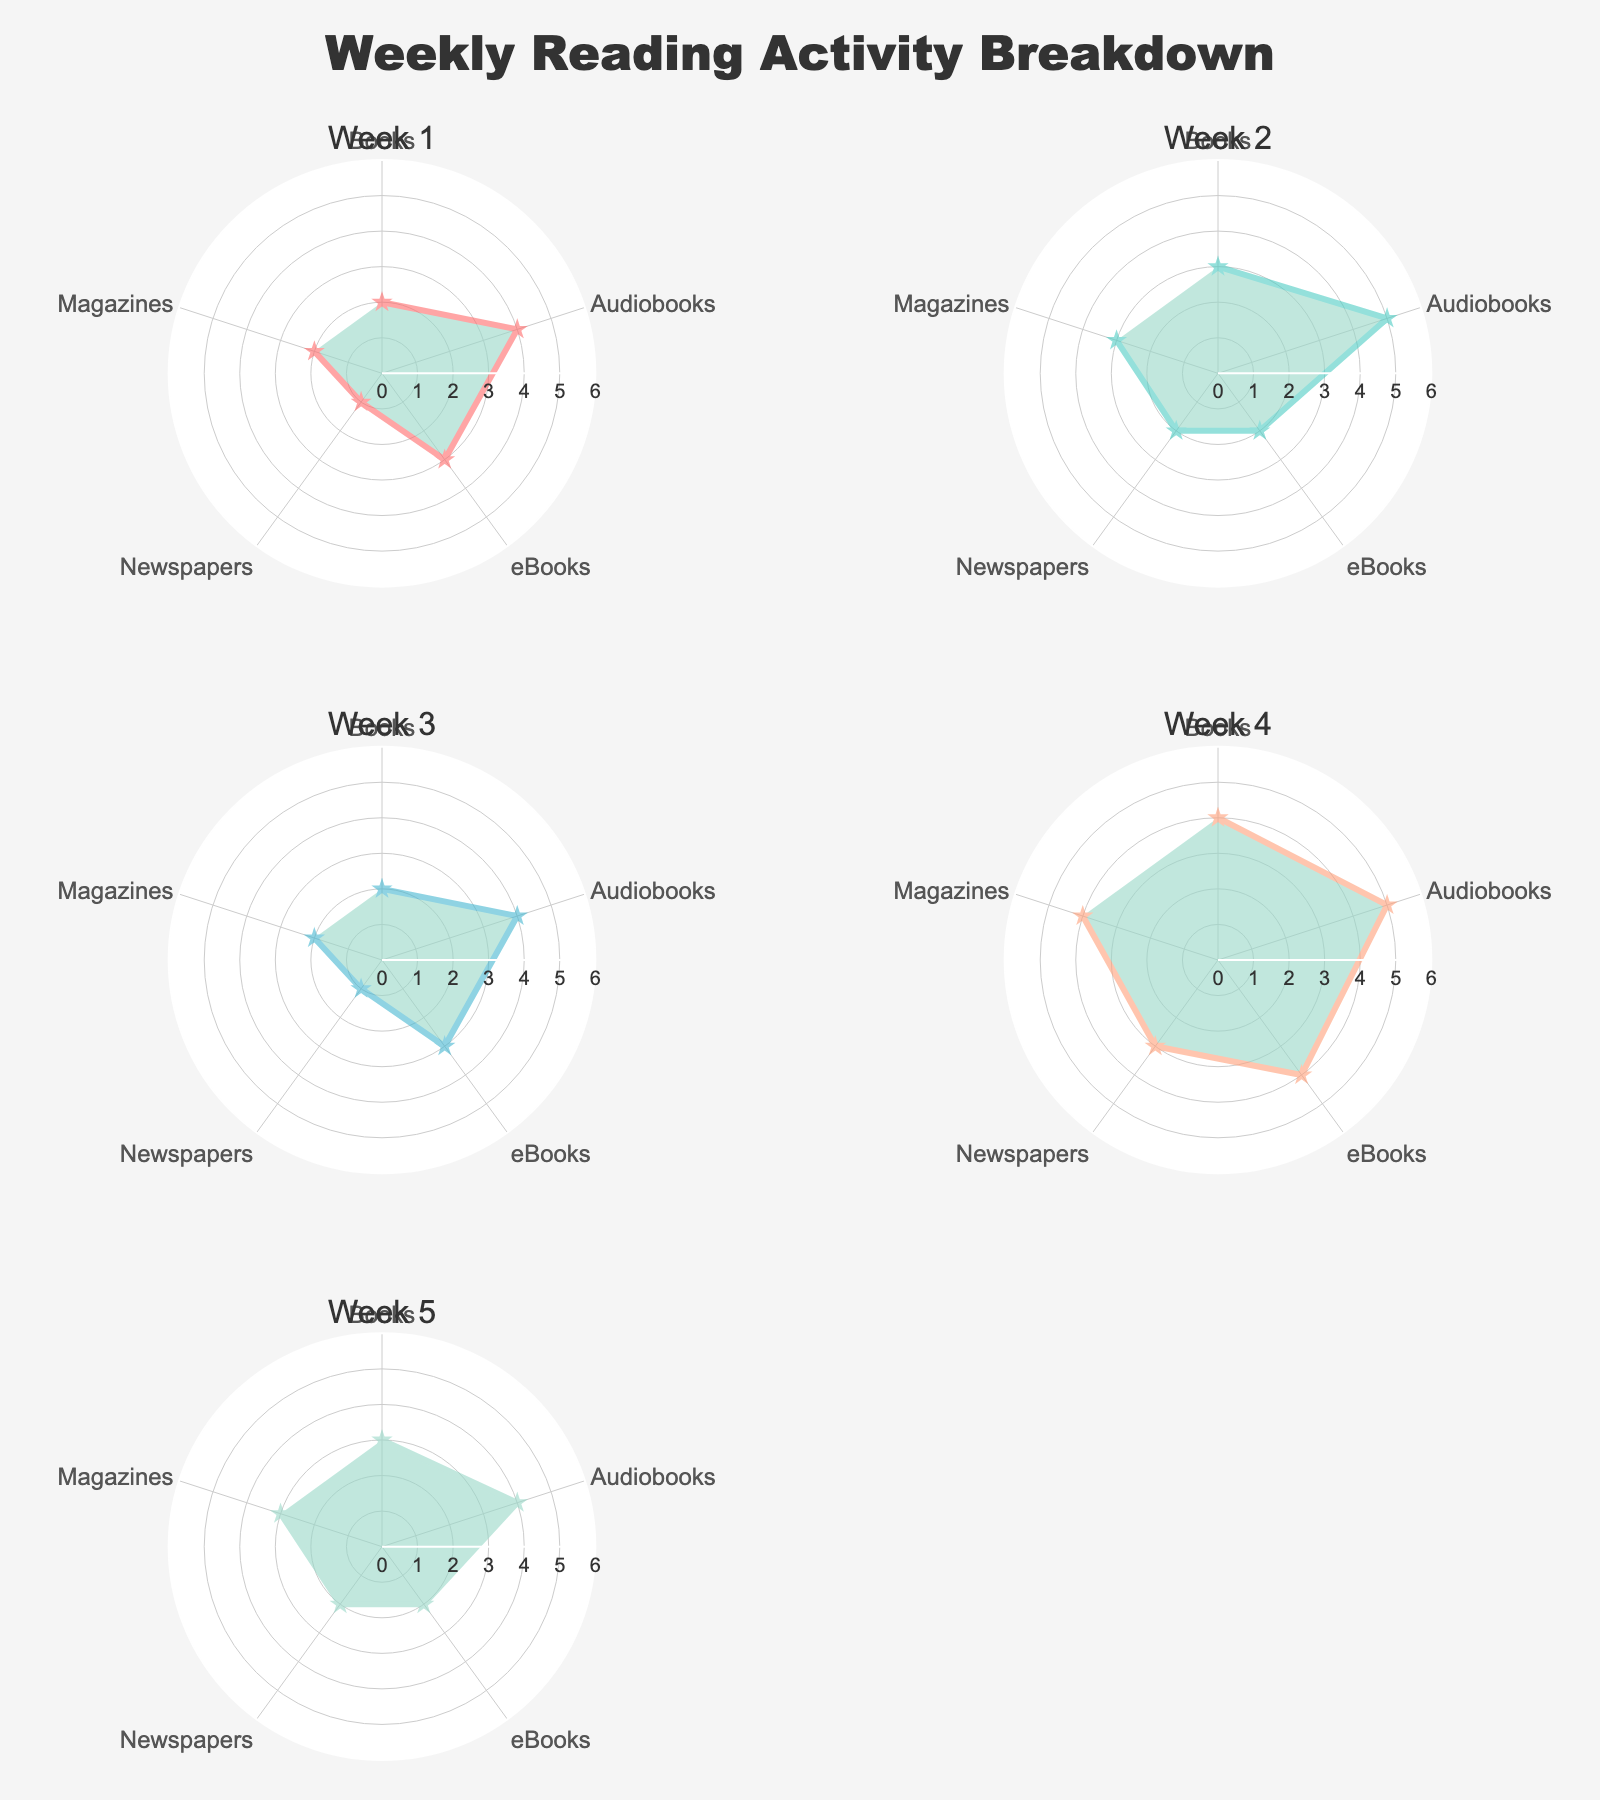What's the title of the figure? The title is located at the top center of the figure. It is styled in large, bold letters. The content of the title can be read directly from the plot.
Answer: Weekly Reading Activity Breakdown How many weeks are represented in the figure? Each subplot represents a week, and the subplot titles list the weeks. By counting these titles, we can determine the total number of weeks.
Answer: 5 Which week shows the highest time spent reading Books? Look at the radar charts for each week and identify the week where the Books category extends the farthest on the radial axis.
Answer: Week 4 What are the categories plotted in each radar chart? Each radar chart plots the same categories. They can be found by looking at the labels around each chart.
Answer: Books, Audiobooks, eBooks, Newspapers, Magazines Which category had the least amount of time spent in Week 5? For Week 5, examine where the value is the smallest on the radar chart, particularly checking which category has the shortest distance from the center.
Answer: eBooks How does the time spent on Audiobooks in Week 3 compare to Week 2? Compare the positions of the Audiobooks category on the radar charts for Week 3 and Week 2. The length of the radius for Audiobooks will indicate the amount of time spent.
Answer: Week 3 is less than Week 2 What's the average time spent reading Newspapers across all weeks? Add the time spent reading Newspapers for each week (1+2+1+3+2), then divide by the number of weeks (5).
Answer: 1.8 Which week shows the most balanced distribution of time among the different categories? Look for the radar chart where the values across all categories are the most even, indicating similar time spent across categories.
Answer: Week 4 What is the range of time spent reading Books over the five weeks? Identify the minimum and maximum values for the Books category across all weeks, then subtract the minimum from the maximum.
Answer: 4 - 2 = 2 Which category shows a consistent reading pattern over the weeks? Examine each category in the radar charts and check for categories where the plotted points do not vary much week to week.
Answer: Magazines 